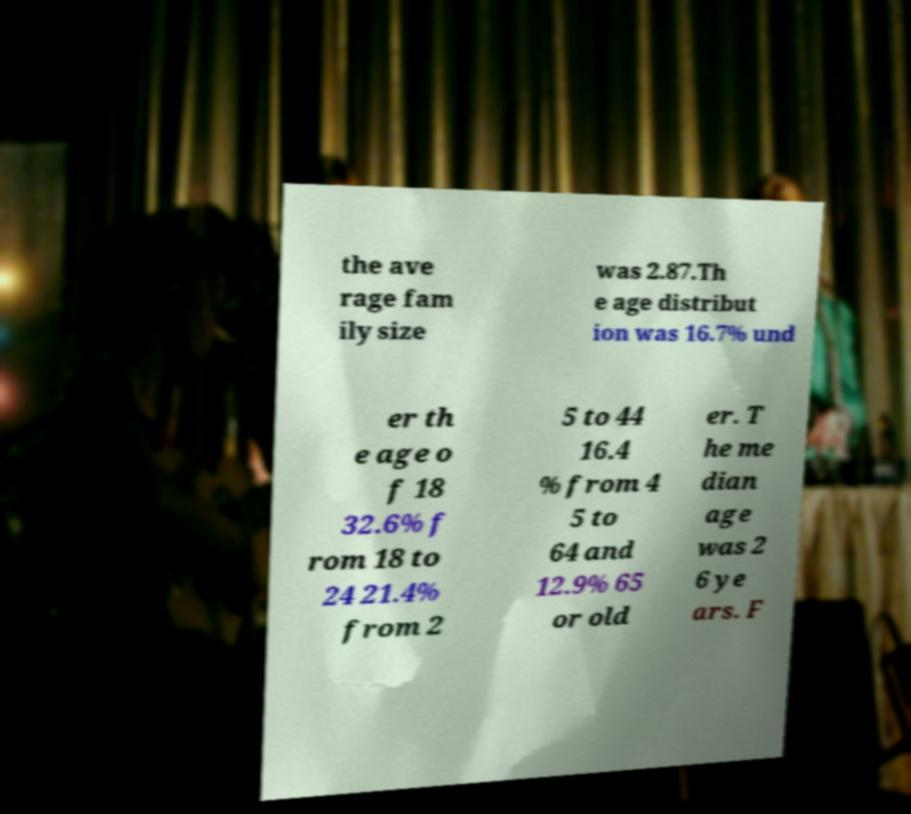Please identify and transcribe the text found in this image. the ave rage fam ily size was 2.87.Th e age distribut ion was 16.7% und er th e age o f 18 32.6% f rom 18 to 24 21.4% from 2 5 to 44 16.4 % from 4 5 to 64 and 12.9% 65 or old er. T he me dian age was 2 6 ye ars. F 